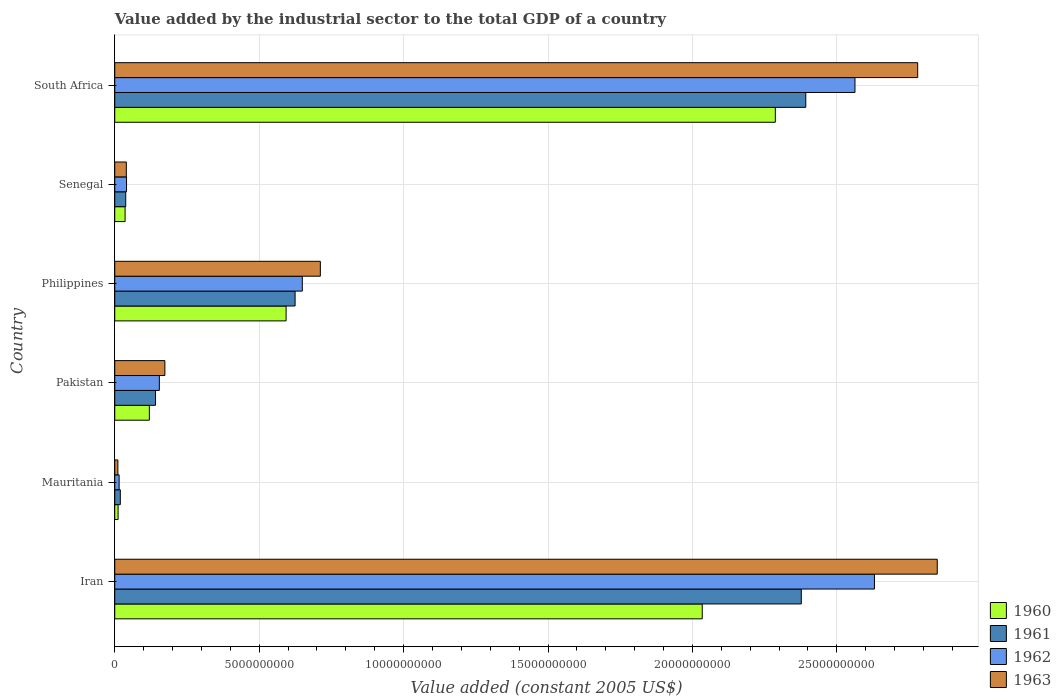Are the number of bars per tick equal to the number of legend labels?
Make the answer very short. Yes. Are the number of bars on each tick of the Y-axis equal?
Your answer should be compact. Yes. What is the label of the 5th group of bars from the top?
Provide a succinct answer. Mauritania. In how many cases, is the number of bars for a given country not equal to the number of legend labels?
Your answer should be compact. 0. What is the value added by the industrial sector in 1963 in Iran?
Provide a short and direct response. 2.85e+1. Across all countries, what is the maximum value added by the industrial sector in 1963?
Offer a terse response. 2.85e+1. Across all countries, what is the minimum value added by the industrial sector in 1962?
Your answer should be very brief. 1.51e+08. In which country was the value added by the industrial sector in 1963 maximum?
Offer a very short reply. Iran. In which country was the value added by the industrial sector in 1962 minimum?
Offer a terse response. Mauritania. What is the total value added by the industrial sector in 1960 in the graph?
Provide a succinct answer. 5.08e+1. What is the difference between the value added by the industrial sector in 1962 in Mauritania and that in Philippines?
Keep it short and to the point. -6.34e+09. What is the difference between the value added by the industrial sector in 1963 in Iran and the value added by the industrial sector in 1961 in South Africa?
Make the answer very short. 4.55e+09. What is the average value added by the industrial sector in 1963 per country?
Your answer should be compact. 1.09e+1. What is the difference between the value added by the industrial sector in 1961 and value added by the industrial sector in 1960 in Philippines?
Offer a terse response. 3.11e+08. What is the ratio of the value added by the industrial sector in 1962 in Iran to that in Pakistan?
Your answer should be compact. 17.04. What is the difference between the highest and the second highest value added by the industrial sector in 1961?
Provide a succinct answer. 1.55e+08. What is the difference between the highest and the lowest value added by the industrial sector in 1962?
Ensure brevity in your answer.  2.62e+1. In how many countries, is the value added by the industrial sector in 1961 greater than the average value added by the industrial sector in 1961 taken over all countries?
Provide a short and direct response. 2. Is it the case that in every country, the sum of the value added by the industrial sector in 1963 and value added by the industrial sector in 1961 is greater than the sum of value added by the industrial sector in 1962 and value added by the industrial sector in 1960?
Offer a very short reply. No. Is it the case that in every country, the sum of the value added by the industrial sector in 1962 and value added by the industrial sector in 1961 is greater than the value added by the industrial sector in 1960?
Offer a very short reply. Yes. How many bars are there?
Keep it short and to the point. 24. Are all the bars in the graph horizontal?
Your answer should be compact. Yes. How many countries are there in the graph?
Make the answer very short. 6. Does the graph contain grids?
Make the answer very short. Yes. Where does the legend appear in the graph?
Ensure brevity in your answer.  Bottom right. How many legend labels are there?
Ensure brevity in your answer.  4. What is the title of the graph?
Offer a terse response. Value added by the industrial sector to the total GDP of a country. Does "1977" appear as one of the legend labels in the graph?
Keep it short and to the point. No. What is the label or title of the X-axis?
Provide a succinct answer. Value added (constant 2005 US$). What is the Value added (constant 2005 US$) of 1960 in Iran?
Offer a terse response. 2.03e+1. What is the Value added (constant 2005 US$) in 1961 in Iran?
Your answer should be compact. 2.38e+1. What is the Value added (constant 2005 US$) in 1962 in Iran?
Your response must be concise. 2.63e+1. What is the Value added (constant 2005 US$) in 1963 in Iran?
Provide a succinct answer. 2.85e+1. What is the Value added (constant 2005 US$) of 1960 in Mauritania?
Offer a terse response. 1.15e+08. What is the Value added (constant 2005 US$) in 1961 in Mauritania?
Give a very brief answer. 1.92e+08. What is the Value added (constant 2005 US$) in 1962 in Mauritania?
Provide a short and direct response. 1.51e+08. What is the Value added (constant 2005 US$) in 1963 in Mauritania?
Make the answer very short. 1.08e+08. What is the Value added (constant 2005 US$) of 1960 in Pakistan?
Offer a terse response. 1.20e+09. What is the Value added (constant 2005 US$) of 1961 in Pakistan?
Your answer should be very brief. 1.41e+09. What is the Value added (constant 2005 US$) in 1962 in Pakistan?
Your answer should be compact. 1.54e+09. What is the Value added (constant 2005 US$) in 1963 in Pakistan?
Provide a short and direct response. 1.74e+09. What is the Value added (constant 2005 US$) of 1960 in Philippines?
Your answer should be very brief. 5.93e+09. What is the Value added (constant 2005 US$) of 1961 in Philippines?
Your answer should be compact. 6.24e+09. What is the Value added (constant 2005 US$) of 1962 in Philippines?
Your response must be concise. 6.49e+09. What is the Value added (constant 2005 US$) in 1963 in Philippines?
Give a very brief answer. 7.12e+09. What is the Value added (constant 2005 US$) of 1960 in Senegal?
Keep it short and to the point. 3.58e+08. What is the Value added (constant 2005 US$) of 1961 in Senegal?
Offer a terse response. 3.80e+08. What is the Value added (constant 2005 US$) in 1962 in Senegal?
Provide a short and direct response. 4.08e+08. What is the Value added (constant 2005 US$) of 1963 in Senegal?
Provide a succinct answer. 4.01e+08. What is the Value added (constant 2005 US$) of 1960 in South Africa?
Your answer should be very brief. 2.29e+1. What is the Value added (constant 2005 US$) of 1961 in South Africa?
Your response must be concise. 2.39e+1. What is the Value added (constant 2005 US$) of 1962 in South Africa?
Make the answer very short. 2.56e+1. What is the Value added (constant 2005 US$) of 1963 in South Africa?
Your response must be concise. 2.78e+1. Across all countries, what is the maximum Value added (constant 2005 US$) of 1960?
Offer a terse response. 2.29e+1. Across all countries, what is the maximum Value added (constant 2005 US$) in 1961?
Provide a short and direct response. 2.39e+1. Across all countries, what is the maximum Value added (constant 2005 US$) in 1962?
Offer a very short reply. 2.63e+1. Across all countries, what is the maximum Value added (constant 2005 US$) of 1963?
Offer a very short reply. 2.85e+1. Across all countries, what is the minimum Value added (constant 2005 US$) in 1960?
Offer a terse response. 1.15e+08. Across all countries, what is the minimum Value added (constant 2005 US$) of 1961?
Your answer should be compact. 1.92e+08. Across all countries, what is the minimum Value added (constant 2005 US$) in 1962?
Keep it short and to the point. 1.51e+08. Across all countries, what is the minimum Value added (constant 2005 US$) in 1963?
Offer a very short reply. 1.08e+08. What is the total Value added (constant 2005 US$) of 1960 in the graph?
Offer a terse response. 5.08e+1. What is the total Value added (constant 2005 US$) of 1961 in the graph?
Make the answer very short. 5.59e+1. What is the total Value added (constant 2005 US$) in 1962 in the graph?
Provide a short and direct response. 6.05e+1. What is the total Value added (constant 2005 US$) in 1963 in the graph?
Ensure brevity in your answer.  6.56e+1. What is the difference between the Value added (constant 2005 US$) of 1960 in Iran and that in Mauritania?
Make the answer very short. 2.02e+1. What is the difference between the Value added (constant 2005 US$) of 1961 in Iran and that in Mauritania?
Give a very brief answer. 2.36e+1. What is the difference between the Value added (constant 2005 US$) in 1962 in Iran and that in Mauritania?
Offer a very short reply. 2.62e+1. What is the difference between the Value added (constant 2005 US$) of 1963 in Iran and that in Mauritania?
Provide a succinct answer. 2.84e+1. What is the difference between the Value added (constant 2005 US$) of 1960 in Iran and that in Pakistan?
Your answer should be compact. 1.91e+1. What is the difference between the Value added (constant 2005 US$) in 1961 in Iran and that in Pakistan?
Make the answer very short. 2.24e+1. What is the difference between the Value added (constant 2005 US$) in 1962 in Iran and that in Pakistan?
Provide a short and direct response. 2.48e+1. What is the difference between the Value added (constant 2005 US$) in 1963 in Iran and that in Pakistan?
Ensure brevity in your answer.  2.67e+1. What is the difference between the Value added (constant 2005 US$) of 1960 in Iran and that in Philippines?
Your answer should be compact. 1.44e+1. What is the difference between the Value added (constant 2005 US$) of 1961 in Iran and that in Philippines?
Offer a terse response. 1.75e+1. What is the difference between the Value added (constant 2005 US$) of 1962 in Iran and that in Philippines?
Provide a succinct answer. 1.98e+1. What is the difference between the Value added (constant 2005 US$) of 1963 in Iran and that in Philippines?
Give a very brief answer. 2.14e+1. What is the difference between the Value added (constant 2005 US$) in 1960 in Iran and that in Senegal?
Your answer should be very brief. 2.00e+1. What is the difference between the Value added (constant 2005 US$) in 1961 in Iran and that in Senegal?
Make the answer very short. 2.34e+1. What is the difference between the Value added (constant 2005 US$) of 1962 in Iran and that in Senegal?
Your answer should be compact. 2.59e+1. What is the difference between the Value added (constant 2005 US$) of 1963 in Iran and that in Senegal?
Keep it short and to the point. 2.81e+1. What is the difference between the Value added (constant 2005 US$) of 1960 in Iran and that in South Africa?
Your answer should be very brief. -2.53e+09. What is the difference between the Value added (constant 2005 US$) in 1961 in Iran and that in South Africa?
Ensure brevity in your answer.  -1.55e+08. What is the difference between the Value added (constant 2005 US$) of 1962 in Iran and that in South Africa?
Provide a succinct answer. 6.75e+08. What is the difference between the Value added (constant 2005 US$) of 1963 in Iran and that in South Africa?
Make the answer very short. 6.77e+08. What is the difference between the Value added (constant 2005 US$) in 1960 in Mauritania and that in Pakistan?
Provide a succinct answer. -1.08e+09. What is the difference between the Value added (constant 2005 US$) in 1961 in Mauritania and that in Pakistan?
Provide a short and direct response. -1.22e+09. What is the difference between the Value added (constant 2005 US$) of 1962 in Mauritania and that in Pakistan?
Give a very brief answer. -1.39e+09. What is the difference between the Value added (constant 2005 US$) of 1963 in Mauritania and that in Pakistan?
Provide a succinct answer. -1.63e+09. What is the difference between the Value added (constant 2005 US$) of 1960 in Mauritania and that in Philippines?
Provide a short and direct response. -5.82e+09. What is the difference between the Value added (constant 2005 US$) of 1961 in Mauritania and that in Philippines?
Ensure brevity in your answer.  -6.05e+09. What is the difference between the Value added (constant 2005 US$) in 1962 in Mauritania and that in Philippines?
Your answer should be compact. -6.34e+09. What is the difference between the Value added (constant 2005 US$) of 1963 in Mauritania and that in Philippines?
Your answer should be very brief. -7.01e+09. What is the difference between the Value added (constant 2005 US$) of 1960 in Mauritania and that in Senegal?
Give a very brief answer. -2.42e+08. What is the difference between the Value added (constant 2005 US$) of 1961 in Mauritania and that in Senegal?
Offer a very short reply. -1.88e+08. What is the difference between the Value added (constant 2005 US$) of 1962 in Mauritania and that in Senegal?
Ensure brevity in your answer.  -2.56e+08. What is the difference between the Value added (constant 2005 US$) in 1963 in Mauritania and that in Senegal?
Provide a succinct answer. -2.92e+08. What is the difference between the Value added (constant 2005 US$) of 1960 in Mauritania and that in South Africa?
Give a very brief answer. -2.28e+1. What is the difference between the Value added (constant 2005 US$) of 1961 in Mauritania and that in South Africa?
Offer a terse response. -2.37e+1. What is the difference between the Value added (constant 2005 US$) of 1962 in Mauritania and that in South Africa?
Offer a terse response. -2.55e+1. What is the difference between the Value added (constant 2005 US$) in 1963 in Mauritania and that in South Africa?
Give a very brief answer. -2.77e+1. What is the difference between the Value added (constant 2005 US$) in 1960 in Pakistan and that in Philippines?
Keep it short and to the point. -4.73e+09. What is the difference between the Value added (constant 2005 US$) of 1961 in Pakistan and that in Philippines?
Provide a succinct answer. -4.83e+09. What is the difference between the Value added (constant 2005 US$) in 1962 in Pakistan and that in Philippines?
Provide a short and direct response. -4.95e+09. What is the difference between the Value added (constant 2005 US$) of 1963 in Pakistan and that in Philippines?
Provide a succinct answer. -5.38e+09. What is the difference between the Value added (constant 2005 US$) of 1960 in Pakistan and that in Senegal?
Provide a succinct answer. 8.40e+08. What is the difference between the Value added (constant 2005 US$) in 1961 in Pakistan and that in Senegal?
Give a very brief answer. 1.03e+09. What is the difference between the Value added (constant 2005 US$) in 1962 in Pakistan and that in Senegal?
Your response must be concise. 1.14e+09. What is the difference between the Value added (constant 2005 US$) in 1963 in Pakistan and that in Senegal?
Offer a very short reply. 1.33e+09. What is the difference between the Value added (constant 2005 US$) of 1960 in Pakistan and that in South Africa?
Your answer should be compact. -2.17e+1. What is the difference between the Value added (constant 2005 US$) in 1961 in Pakistan and that in South Africa?
Keep it short and to the point. -2.25e+1. What is the difference between the Value added (constant 2005 US$) in 1962 in Pakistan and that in South Africa?
Keep it short and to the point. -2.41e+1. What is the difference between the Value added (constant 2005 US$) of 1963 in Pakistan and that in South Africa?
Your answer should be very brief. -2.61e+1. What is the difference between the Value added (constant 2005 US$) of 1960 in Philippines and that in Senegal?
Provide a short and direct response. 5.57e+09. What is the difference between the Value added (constant 2005 US$) in 1961 in Philippines and that in Senegal?
Give a very brief answer. 5.86e+09. What is the difference between the Value added (constant 2005 US$) of 1962 in Philippines and that in Senegal?
Give a very brief answer. 6.09e+09. What is the difference between the Value added (constant 2005 US$) of 1963 in Philippines and that in Senegal?
Your answer should be very brief. 6.72e+09. What is the difference between the Value added (constant 2005 US$) of 1960 in Philippines and that in South Africa?
Offer a very short reply. -1.69e+1. What is the difference between the Value added (constant 2005 US$) in 1961 in Philippines and that in South Africa?
Offer a terse response. -1.77e+1. What is the difference between the Value added (constant 2005 US$) in 1962 in Philippines and that in South Africa?
Make the answer very short. -1.91e+1. What is the difference between the Value added (constant 2005 US$) of 1963 in Philippines and that in South Africa?
Provide a short and direct response. -2.07e+1. What is the difference between the Value added (constant 2005 US$) of 1960 in Senegal and that in South Africa?
Offer a terse response. -2.25e+1. What is the difference between the Value added (constant 2005 US$) of 1961 in Senegal and that in South Africa?
Your answer should be compact. -2.35e+1. What is the difference between the Value added (constant 2005 US$) in 1962 in Senegal and that in South Africa?
Provide a short and direct response. -2.52e+1. What is the difference between the Value added (constant 2005 US$) of 1963 in Senegal and that in South Africa?
Offer a very short reply. -2.74e+1. What is the difference between the Value added (constant 2005 US$) in 1960 in Iran and the Value added (constant 2005 US$) in 1961 in Mauritania?
Your answer should be very brief. 2.01e+1. What is the difference between the Value added (constant 2005 US$) of 1960 in Iran and the Value added (constant 2005 US$) of 1962 in Mauritania?
Make the answer very short. 2.02e+1. What is the difference between the Value added (constant 2005 US$) in 1960 in Iran and the Value added (constant 2005 US$) in 1963 in Mauritania?
Ensure brevity in your answer.  2.02e+1. What is the difference between the Value added (constant 2005 US$) in 1961 in Iran and the Value added (constant 2005 US$) in 1962 in Mauritania?
Your response must be concise. 2.36e+1. What is the difference between the Value added (constant 2005 US$) in 1961 in Iran and the Value added (constant 2005 US$) in 1963 in Mauritania?
Offer a very short reply. 2.37e+1. What is the difference between the Value added (constant 2005 US$) of 1962 in Iran and the Value added (constant 2005 US$) of 1963 in Mauritania?
Offer a very short reply. 2.62e+1. What is the difference between the Value added (constant 2005 US$) in 1960 in Iran and the Value added (constant 2005 US$) in 1961 in Pakistan?
Your response must be concise. 1.89e+1. What is the difference between the Value added (constant 2005 US$) of 1960 in Iran and the Value added (constant 2005 US$) of 1962 in Pakistan?
Your answer should be very brief. 1.88e+1. What is the difference between the Value added (constant 2005 US$) in 1960 in Iran and the Value added (constant 2005 US$) in 1963 in Pakistan?
Offer a terse response. 1.86e+1. What is the difference between the Value added (constant 2005 US$) of 1961 in Iran and the Value added (constant 2005 US$) of 1962 in Pakistan?
Make the answer very short. 2.22e+1. What is the difference between the Value added (constant 2005 US$) of 1961 in Iran and the Value added (constant 2005 US$) of 1963 in Pakistan?
Offer a terse response. 2.20e+1. What is the difference between the Value added (constant 2005 US$) in 1962 in Iran and the Value added (constant 2005 US$) in 1963 in Pakistan?
Give a very brief answer. 2.46e+1. What is the difference between the Value added (constant 2005 US$) of 1960 in Iran and the Value added (constant 2005 US$) of 1961 in Philippines?
Provide a succinct answer. 1.41e+1. What is the difference between the Value added (constant 2005 US$) in 1960 in Iran and the Value added (constant 2005 US$) in 1962 in Philippines?
Provide a short and direct response. 1.38e+1. What is the difference between the Value added (constant 2005 US$) of 1960 in Iran and the Value added (constant 2005 US$) of 1963 in Philippines?
Ensure brevity in your answer.  1.32e+1. What is the difference between the Value added (constant 2005 US$) in 1961 in Iran and the Value added (constant 2005 US$) in 1962 in Philippines?
Ensure brevity in your answer.  1.73e+1. What is the difference between the Value added (constant 2005 US$) in 1961 in Iran and the Value added (constant 2005 US$) in 1963 in Philippines?
Give a very brief answer. 1.67e+1. What is the difference between the Value added (constant 2005 US$) of 1962 in Iran and the Value added (constant 2005 US$) of 1963 in Philippines?
Keep it short and to the point. 1.92e+1. What is the difference between the Value added (constant 2005 US$) in 1960 in Iran and the Value added (constant 2005 US$) in 1961 in Senegal?
Ensure brevity in your answer.  2.00e+1. What is the difference between the Value added (constant 2005 US$) in 1960 in Iran and the Value added (constant 2005 US$) in 1962 in Senegal?
Ensure brevity in your answer.  1.99e+1. What is the difference between the Value added (constant 2005 US$) of 1960 in Iran and the Value added (constant 2005 US$) of 1963 in Senegal?
Your answer should be compact. 1.99e+1. What is the difference between the Value added (constant 2005 US$) in 1961 in Iran and the Value added (constant 2005 US$) in 1962 in Senegal?
Provide a short and direct response. 2.34e+1. What is the difference between the Value added (constant 2005 US$) in 1961 in Iran and the Value added (constant 2005 US$) in 1963 in Senegal?
Offer a terse response. 2.34e+1. What is the difference between the Value added (constant 2005 US$) of 1962 in Iran and the Value added (constant 2005 US$) of 1963 in Senegal?
Keep it short and to the point. 2.59e+1. What is the difference between the Value added (constant 2005 US$) in 1960 in Iran and the Value added (constant 2005 US$) in 1961 in South Africa?
Give a very brief answer. -3.58e+09. What is the difference between the Value added (constant 2005 US$) of 1960 in Iran and the Value added (constant 2005 US$) of 1962 in South Africa?
Your response must be concise. -5.29e+09. What is the difference between the Value added (constant 2005 US$) of 1960 in Iran and the Value added (constant 2005 US$) of 1963 in South Africa?
Keep it short and to the point. -7.46e+09. What is the difference between the Value added (constant 2005 US$) of 1961 in Iran and the Value added (constant 2005 US$) of 1962 in South Africa?
Provide a short and direct response. -1.86e+09. What is the difference between the Value added (constant 2005 US$) of 1961 in Iran and the Value added (constant 2005 US$) of 1963 in South Africa?
Ensure brevity in your answer.  -4.03e+09. What is the difference between the Value added (constant 2005 US$) of 1962 in Iran and the Value added (constant 2005 US$) of 1963 in South Africa?
Keep it short and to the point. -1.50e+09. What is the difference between the Value added (constant 2005 US$) of 1960 in Mauritania and the Value added (constant 2005 US$) of 1961 in Pakistan?
Offer a terse response. -1.30e+09. What is the difference between the Value added (constant 2005 US$) in 1960 in Mauritania and the Value added (constant 2005 US$) in 1962 in Pakistan?
Ensure brevity in your answer.  -1.43e+09. What is the difference between the Value added (constant 2005 US$) of 1960 in Mauritania and the Value added (constant 2005 US$) of 1963 in Pakistan?
Offer a terse response. -1.62e+09. What is the difference between the Value added (constant 2005 US$) of 1961 in Mauritania and the Value added (constant 2005 US$) of 1962 in Pakistan?
Offer a terse response. -1.35e+09. What is the difference between the Value added (constant 2005 US$) of 1961 in Mauritania and the Value added (constant 2005 US$) of 1963 in Pakistan?
Make the answer very short. -1.54e+09. What is the difference between the Value added (constant 2005 US$) of 1962 in Mauritania and the Value added (constant 2005 US$) of 1963 in Pakistan?
Offer a very short reply. -1.58e+09. What is the difference between the Value added (constant 2005 US$) in 1960 in Mauritania and the Value added (constant 2005 US$) in 1961 in Philippines?
Your response must be concise. -6.13e+09. What is the difference between the Value added (constant 2005 US$) in 1960 in Mauritania and the Value added (constant 2005 US$) in 1962 in Philippines?
Provide a succinct answer. -6.38e+09. What is the difference between the Value added (constant 2005 US$) in 1960 in Mauritania and the Value added (constant 2005 US$) in 1963 in Philippines?
Keep it short and to the point. -7.00e+09. What is the difference between the Value added (constant 2005 US$) of 1961 in Mauritania and the Value added (constant 2005 US$) of 1962 in Philippines?
Give a very brief answer. -6.30e+09. What is the difference between the Value added (constant 2005 US$) in 1961 in Mauritania and the Value added (constant 2005 US$) in 1963 in Philippines?
Keep it short and to the point. -6.93e+09. What is the difference between the Value added (constant 2005 US$) in 1962 in Mauritania and the Value added (constant 2005 US$) in 1963 in Philippines?
Provide a succinct answer. -6.97e+09. What is the difference between the Value added (constant 2005 US$) of 1960 in Mauritania and the Value added (constant 2005 US$) of 1961 in Senegal?
Provide a short and direct response. -2.65e+08. What is the difference between the Value added (constant 2005 US$) in 1960 in Mauritania and the Value added (constant 2005 US$) in 1962 in Senegal?
Keep it short and to the point. -2.92e+08. What is the difference between the Value added (constant 2005 US$) in 1960 in Mauritania and the Value added (constant 2005 US$) in 1963 in Senegal?
Keep it short and to the point. -2.85e+08. What is the difference between the Value added (constant 2005 US$) of 1961 in Mauritania and the Value added (constant 2005 US$) of 1962 in Senegal?
Your answer should be very brief. -2.15e+08. What is the difference between the Value added (constant 2005 US$) of 1961 in Mauritania and the Value added (constant 2005 US$) of 1963 in Senegal?
Keep it short and to the point. -2.08e+08. What is the difference between the Value added (constant 2005 US$) of 1962 in Mauritania and the Value added (constant 2005 US$) of 1963 in Senegal?
Your answer should be compact. -2.49e+08. What is the difference between the Value added (constant 2005 US$) of 1960 in Mauritania and the Value added (constant 2005 US$) of 1961 in South Africa?
Keep it short and to the point. -2.38e+1. What is the difference between the Value added (constant 2005 US$) of 1960 in Mauritania and the Value added (constant 2005 US$) of 1962 in South Africa?
Your answer should be compact. -2.55e+1. What is the difference between the Value added (constant 2005 US$) in 1960 in Mauritania and the Value added (constant 2005 US$) in 1963 in South Africa?
Give a very brief answer. -2.77e+1. What is the difference between the Value added (constant 2005 US$) in 1961 in Mauritania and the Value added (constant 2005 US$) in 1962 in South Africa?
Make the answer very short. -2.54e+1. What is the difference between the Value added (constant 2005 US$) of 1961 in Mauritania and the Value added (constant 2005 US$) of 1963 in South Africa?
Offer a very short reply. -2.76e+1. What is the difference between the Value added (constant 2005 US$) of 1962 in Mauritania and the Value added (constant 2005 US$) of 1963 in South Africa?
Your answer should be very brief. -2.76e+1. What is the difference between the Value added (constant 2005 US$) of 1960 in Pakistan and the Value added (constant 2005 US$) of 1961 in Philippines?
Offer a very short reply. -5.05e+09. What is the difference between the Value added (constant 2005 US$) in 1960 in Pakistan and the Value added (constant 2005 US$) in 1962 in Philippines?
Give a very brief answer. -5.30e+09. What is the difference between the Value added (constant 2005 US$) in 1960 in Pakistan and the Value added (constant 2005 US$) in 1963 in Philippines?
Your answer should be compact. -5.92e+09. What is the difference between the Value added (constant 2005 US$) in 1961 in Pakistan and the Value added (constant 2005 US$) in 1962 in Philippines?
Your answer should be compact. -5.08e+09. What is the difference between the Value added (constant 2005 US$) in 1961 in Pakistan and the Value added (constant 2005 US$) in 1963 in Philippines?
Keep it short and to the point. -5.71e+09. What is the difference between the Value added (constant 2005 US$) of 1962 in Pakistan and the Value added (constant 2005 US$) of 1963 in Philippines?
Ensure brevity in your answer.  -5.57e+09. What is the difference between the Value added (constant 2005 US$) in 1960 in Pakistan and the Value added (constant 2005 US$) in 1961 in Senegal?
Your response must be concise. 8.18e+08. What is the difference between the Value added (constant 2005 US$) of 1960 in Pakistan and the Value added (constant 2005 US$) of 1962 in Senegal?
Make the answer very short. 7.91e+08. What is the difference between the Value added (constant 2005 US$) of 1960 in Pakistan and the Value added (constant 2005 US$) of 1963 in Senegal?
Make the answer very short. 7.98e+08. What is the difference between the Value added (constant 2005 US$) of 1961 in Pakistan and the Value added (constant 2005 US$) of 1962 in Senegal?
Keep it short and to the point. 1.00e+09. What is the difference between the Value added (constant 2005 US$) of 1961 in Pakistan and the Value added (constant 2005 US$) of 1963 in Senegal?
Give a very brief answer. 1.01e+09. What is the difference between the Value added (constant 2005 US$) of 1962 in Pakistan and the Value added (constant 2005 US$) of 1963 in Senegal?
Provide a short and direct response. 1.14e+09. What is the difference between the Value added (constant 2005 US$) of 1960 in Pakistan and the Value added (constant 2005 US$) of 1961 in South Africa?
Provide a succinct answer. -2.27e+1. What is the difference between the Value added (constant 2005 US$) in 1960 in Pakistan and the Value added (constant 2005 US$) in 1962 in South Africa?
Your answer should be compact. -2.44e+1. What is the difference between the Value added (constant 2005 US$) of 1960 in Pakistan and the Value added (constant 2005 US$) of 1963 in South Africa?
Provide a short and direct response. -2.66e+1. What is the difference between the Value added (constant 2005 US$) in 1961 in Pakistan and the Value added (constant 2005 US$) in 1962 in South Africa?
Ensure brevity in your answer.  -2.42e+1. What is the difference between the Value added (constant 2005 US$) of 1961 in Pakistan and the Value added (constant 2005 US$) of 1963 in South Africa?
Keep it short and to the point. -2.64e+1. What is the difference between the Value added (constant 2005 US$) in 1962 in Pakistan and the Value added (constant 2005 US$) in 1963 in South Africa?
Your answer should be very brief. -2.63e+1. What is the difference between the Value added (constant 2005 US$) of 1960 in Philippines and the Value added (constant 2005 US$) of 1961 in Senegal?
Make the answer very short. 5.55e+09. What is the difference between the Value added (constant 2005 US$) in 1960 in Philippines and the Value added (constant 2005 US$) in 1962 in Senegal?
Provide a short and direct response. 5.53e+09. What is the difference between the Value added (constant 2005 US$) in 1960 in Philippines and the Value added (constant 2005 US$) in 1963 in Senegal?
Keep it short and to the point. 5.53e+09. What is the difference between the Value added (constant 2005 US$) in 1961 in Philippines and the Value added (constant 2005 US$) in 1962 in Senegal?
Provide a short and direct response. 5.84e+09. What is the difference between the Value added (constant 2005 US$) of 1961 in Philippines and the Value added (constant 2005 US$) of 1963 in Senegal?
Ensure brevity in your answer.  5.84e+09. What is the difference between the Value added (constant 2005 US$) in 1962 in Philippines and the Value added (constant 2005 US$) in 1963 in Senegal?
Offer a very short reply. 6.09e+09. What is the difference between the Value added (constant 2005 US$) in 1960 in Philippines and the Value added (constant 2005 US$) in 1961 in South Africa?
Make the answer very short. -1.80e+1. What is the difference between the Value added (constant 2005 US$) in 1960 in Philippines and the Value added (constant 2005 US$) in 1962 in South Africa?
Ensure brevity in your answer.  -1.97e+1. What is the difference between the Value added (constant 2005 US$) of 1960 in Philippines and the Value added (constant 2005 US$) of 1963 in South Africa?
Your answer should be very brief. -2.19e+1. What is the difference between the Value added (constant 2005 US$) of 1961 in Philippines and the Value added (constant 2005 US$) of 1962 in South Africa?
Offer a terse response. -1.94e+1. What is the difference between the Value added (constant 2005 US$) of 1961 in Philippines and the Value added (constant 2005 US$) of 1963 in South Africa?
Offer a terse response. -2.16e+1. What is the difference between the Value added (constant 2005 US$) of 1962 in Philippines and the Value added (constant 2005 US$) of 1963 in South Africa?
Provide a short and direct response. -2.13e+1. What is the difference between the Value added (constant 2005 US$) in 1960 in Senegal and the Value added (constant 2005 US$) in 1961 in South Africa?
Provide a succinct answer. -2.36e+1. What is the difference between the Value added (constant 2005 US$) in 1960 in Senegal and the Value added (constant 2005 US$) in 1962 in South Africa?
Your answer should be compact. -2.53e+1. What is the difference between the Value added (constant 2005 US$) in 1960 in Senegal and the Value added (constant 2005 US$) in 1963 in South Africa?
Ensure brevity in your answer.  -2.74e+1. What is the difference between the Value added (constant 2005 US$) of 1961 in Senegal and the Value added (constant 2005 US$) of 1962 in South Africa?
Give a very brief answer. -2.52e+1. What is the difference between the Value added (constant 2005 US$) in 1961 in Senegal and the Value added (constant 2005 US$) in 1963 in South Africa?
Offer a terse response. -2.74e+1. What is the difference between the Value added (constant 2005 US$) of 1962 in Senegal and the Value added (constant 2005 US$) of 1963 in South Africa?
Ensure brevity in your answer.  -2.74e+1. What is the average Value added (constant 2005 US$) in 1960 per country?
Your answer should be very brief. 8.47e+09. What is the average Value added (constant 2005 US$) in 1961 per country?
Give a very brief answer. 9.32e+09. What is the average Value added (constant 2005 US$) of 1962 per country?
Keep it short and to the point. 1.01e+1. What is the average Value added (constant 2005 US$) in 1963 per country?
Offer a terse response. 1.09e+1. What is the difference between the Value added (constant 2005 US$) in 1960 and Value added (constant 2005 US$) in 1961 in Iran?
Offer a terse response. -3.43e+09. What is the difference between the Value added (constant 2005 US$) in 1960 and Value added (constant 2005 US$) in 1962 in Iran?
Give a very brief answer. -5.96e+09. What is the difference between the Value added (constant 2005 US$) in 1960 and Value added (constant 2005 US$) in 1963 in Iran?
Provide a short and direct response. -8.14e+09. What is the difference between the Value added (constant 2005 US$) of 1961 and Value added (constant 2005 US$) of 1962 in Iran?
Provide a short and direct response. -2.53e+09. What is the difference between the Value added (constant 2005 US$) in 1961 and Value added (constant 2005 US$) in 1963 in Iran?
Provide a succinct answer. -4.71e+09. What is the difference between the Value added (constant 2005 US$) in 1962 and Value added (constant 2005 US$) in 1963 in Iran?
Provide a succinct answer. -2.17e+09. What is the difference between the Value added (constant 2005 US$) in 1960 and Value added (constant 2005 US$) in 1961 in Mauritania?
Provide a short and direct response. -7.68e+07. What is the difference between the Value added (constant 2005 US$) of 1960 and Value added (constant 2005 US$) of 1962 in Mauritania?
Your answer should be very brief. -3.59e+07. What is the difference between the Value added (constant 2005 US$) of 1960 and Value added (constant 2005 US$) of 1963 in Mauritania?
Ensure brevity in your answer.  7.13e+06. What is the difference between the Value added (constant 2005 US$) in 1961 and Value added (constant 2005 US$) in 1962 in Mauritania?
Keep it short and to the point. 4.09e+07. What is the difference between the Value added (constant 2005 US$) in 1961 and Value added (constant 2005 US$) in 1963 in Mauritania?
Make the answer very short. 8.39e+07. What is the difference between the Value added (constant 2005 US$) in 1962 and Value added (constant 2005 US$) in 1963 in Mauritania?
Offer a terse response. 4.31e+07. What is the difference between the Value added (constant 2005 US$) of 1960 and Value added (constant 2005 US$) of 1961 in Pakistan?
Provide a succinct answer. -2.14e+08. What is the difference between the Value added (constant 2005 US$) in 1960 and Value added (constant 2005 US$) in 1962 in Pakistan?
Your answer should be compact. -3.45e+08. What is the difference between the Value added (constant 2005 US$) of 1960 and Value added (constant 2005 US$) of 1963 in Pakistan?
Your response must be concise. -5.37e+08. What is the difference between the Value added (constant 2005 US$) in 1961 and Value added (constant 2005 US$) in 1962 in Pakistan?
Your response must be concise. -1.32e+08. What is the difference between the Value added (constant 2005 US$) in 1961 and Value added (constant 2005 US$) in 1963 in Pakistan?
Provide a succinct answer. -3.23e+08. What is the difference between the Value added (constant 2005 US$) in 1962 and Value added (constant 2005 US$) in 1963 in Pakistan?
Offer a terse response. -1.92e+08. What is the difference between the Value added (constant 2005 US$) of 1960 and Value added (constant 2005 US$) of 1961 in Philippines?
Make the answer very short. -3.11e+08. What is the difference between the Value added (constant 2005 US$) of 1960 and Value added (constant 2005 US$) of 1962 in Philippines?
Give a very brief answer. -5.61e+08. What is the difference between the Value added (constant 2005 US$) in 1960 and Value added (constant 2005 US$) in 1963 in Philippines?
Offer a very short reply. -1.18e+09. What is the difference between the Value added (constant 2005 US$) in 1961 and Value added (constant 2005 US$) in 1962 in Philippines?
Provide a short and direct response. -2.50e+08. What is the difference between the Value added (constant 2005 US$) in 1961 and Value added (constant 2005 US$) in 1963 in Philippines?
Your answer should be very brief. -8.74e+08. What is the difference between the Value added (constant 2005 US$) of 1962 and Value added (constant 2005 US$) of 1963 in Philippines?
Your response must be concise. -6.24e+08. What is the difference between the Value added (constant 2005 US$) of 1960 and Value added (constant 2005 US$) of 1961 in Senegal?
Make the answer very short. -2.25e+07. What is the difference between the Value added (constant 2005 US$) of 1960 and Value added (constant 2005 US$) of 1962 in Senegal?
Your answer should be very brief. -4.98e+07. What is the difference between the Value added (constant 2005 US$) in 1960 and Value added (constant 2005 US$) in 1963 in Senegal?
Ensure brevity in your answer.  -4.27e+07. What is the difference between the Value added (constant 2005 US$) of 1961 and Value added (constant 2005 US$) of 1962 in Senegal?
Provide a succinct answer. -2.72e+07. What is the difference between the Value added (constant 2005 US$) in 1961 and Value added (constant 2005 US$) in 1963 in Senegal?
Provide a short and direct response. -2.02e+07. What is the difference between the Value added (constant 2005 US$) of 1962 and Value added (constant 2005 US$) of 1963 in Senegal?
Your answer should be very brief. 7.03e+06. What is the difference between the Value added (constant 2005 US$) of 1960 and Value added (constant 2005 US$) of 1961 in South Africa?
Your answer should be compact. -1.05e+09. What is the difference between the Value added (constant 2005 US$) in 1960 and Value added (constant 2005 US$) in 1962 in South Africa?
Keep it short and to the point. -2.76e+09. What is the difference between the Value added (constant 2005 US$) in 1960 and Value added (constant 2005 US$) in 1963 in South Africa?
Provide a short and direct response. -4.93e+09. What is the difference between the Value added (constant 2005 US$) of 1961 and Value added (constant 2005 US$) of 1962 in South Africa?
Provide a short and direct response. -1.70e+09. What is the difference between the Value added (constant 2005 US$) of 1961 and Value added (constant 2005 US$) of 1963 in South Africa?
Provide a short and direct response. -3.87e+09. What is the difference between the Value added (constant 2005 US$) in 1962 and Value added (constant 2005 US$) in 1963 in South Africa?
Make the answer very short. -2.17e+09. What is the ratio of the Value added (constant 2005 US$) of 1960 in Iran to that in Mauritania?
Keep it short and to the point. 176.32. What is the ratio of the Value added (constant 2005 US$) of 1961 in Iran to that in Mauritania?
Ensure brevity in your answer.  123.7. What is the ratio of the Value added (constant 2005 US$) of 1962 in Iran to that in Mauritania?
Give a very brief answer. 173.84. What is the ratio of the Value added (constant 2005 US$) in 1963 in Iran to that in Mauritania?
Give a very brief answer. 263.11. What is the ratio of the Value added (constant 2005 US$) of 1960 in Iran to that in Pakistan?
Ensure brevity in your answer.  16.98. What is the ratio of the Value added (constant 2005 US$) in 1961 in Iran to that in Pakistan?
Your answer should be compact. 16.84. What is the ratio of the Value added (constant 2005 US$) of 1962 in Iran to that in Pakistan?
Provide a short and direct response. 17.04. What is the ratio of the Value added (constant 2005 US$) in 1963 in Iran to that in Pakistan?
Offer a terse response. 16.41. What is the ratio of the Value added (constant 2005 US$) of 1960 in Iran to that in Philippines?
Make the answer very short. 3.43. What is the ratio of the Value added (constant 2005 US$) of 1961 in Iran to that in Philippines?
Your answer should be compact. 3.81. What is the ratio of the Value added (constant 2005 US$) in 1962 in Iran to that in Philippines?
Ensure brevity in your answer.  4.05. What is the ratio of the Value added (constant 2005 US$) in 1963 in Iran to that in Philippines?
Your response must be concise. 4. What is the ratio of the Value added (constant 2005 US$) in 1960 in Iran to that in Senegal?
Make the answer very short. 56.85. What is the ratio of the Value added (constant 2005 US$) in 1961 in Iran to that in Senegal?
Your answer should be compact. 62.5. What is the ratio of the Value added (constant 2005 US$) in 1962 in Iran to that in Senegal?
Keep it short and to the point. 64.54. What is the ratio of the Value added (constant 2005 US$) of 1963 in Iran to that in Senegal?
Offer a terse response. 71.1. What is the ratio of the Value added (constant 2005 US$) of 1960 in Iran to that in South Africa?
Offer a very short reply. 0.89. What is the ratio of the Value added (constant 2005 US$) of 1961 in Iran to that in South Africa?
Keep it short and to the point. 0.99. What is the ratio of the Value added (constant 2005 US$) in 1962 in Iran to that in South Africa?
Your answer should be compact. 1.03. What is the ratio of the Value added (constant 2005 US$) of 1963 in Iran to that in South Africa?
Your answer should be compact. 1.02. What is the ratio of the Value added (constant 2005 US$) in 1960 in Mauritania to that in Pakistan?
Offer a terse response. 0.1. What is the ratio of the Value added (constant 2005 US$) in 1961 in Mauritania to that in Pakistan?
Offer a very short reply. 0.14. What is the ratio of the Value added (constant 2005 US$) in 1962 in Mauritania to that in Pakistan?
Keep it short and to the point. 0.1. What is the ratio of the Value added (constant 2005 US$) in 1963 in Mauritania to that in Pakistan?
Make the answer very short. 0.06. What is the ratio of the Value added (constant 2005 US$) of 1960 in Mauritania to that in Philippines?
Give a very brief answer. 0.02. What is the ratio of the Value added (constant 2005 US$) of 1961 in Mauritania to that in Philippines?
Offer a very short reply. 0.03. What is the ratio of the Value added (constant 2005 US$) of 1962 in Mauritania to that in Philippines?
Provide a succinct answer. 0.02. What is the ratio of the Value added (constant 2005 US$) of 1963 in Mauritania to that in Philippines?
Your answer should be very brief. 0.02. What is the ratio of the Value added (constant 2005 US$) of 1960 in Mauritania to that in Senegal?
Offer a terse response. 0.32. What is the ratio of the Value added (constant 2005 US$) of 1961 in Mauritania to that in Senegal?
Keep it short and to the point. 0.51. What is the ratio of the Value added (constant 2005 US$) of 1962 in Mauritania to that in Senegal?
Provide a short and direct response. 0.37. What is the ratio of the Value added (constant 2005 US$) in 1963 in Mauritania to that in Senegal?
Your answer should be compact. 0.27. What is the ratio of the Value added (constant 2005 US$) in 1960 in Mauritania to that in South Africa?
Your answer should be compact. 0.01. What is the ratio of the Value added (constant 2005 US$) in 1961 in Mauritania to that in South Africa?
Give a very brief answer. 0.01. What is the ratio of the Value added (constant 2005 US$) of 1962 in Mauritania to that in South Africa?
Your answer should be compact. 0.01. What is the ratio of the Value added (constant 2005 US$) of 1963 in Mauritania to that in South Africa?
Offer a terse response. 0. What is the ratio of the Value added (constant 2005 US$) in 1960 in Pakistan to that in Philippines?
Make the answer very short. 0.2. What is the ratio of the Value added (constant 2005 US$) of 1961 in Pakistan to that in Philippines?
Provide a short and direct response. 0.23. What is the ratio of the Value added (constant 2005 US$) in 1962 in Pakistan to that in Philippines?
Your response must be concise. 0.24. What is the ratio of the Value added (constant 2005 US$) of 1963 in Pakistan to that in Philippines?
Offer a very short reply. 0.24. What is the ratio of the Value added (constant 2005 US$) in 1960 in Pakistan to that in Senegal?
Keep it short and to the point. 3.35. What is the ratio of the Value added (constant 2005 US$) of 1961 in Pakistan to that in Senegal?
Provide a short and direct response. 3.71. What is the ratio of the Value added (constant 2005 US$) of 1962 in Pakistan to that in Senegal?
Offer a very short reply. 3.79. What is the ratio of the Value added (constant 2005 US$) of 1963 in Pakistan to that in Senegal?
Provide a succinct answer. 4.33. What is the ratio of the Value added (constant 2005 US$) in 1960 in Pakistan to that in South Africa?
Give a very brief answer. 0.05. What is the ratio of the Value added (constant 2005 US$) of 1961 in Pakistan to that in South Africa?
Make the answer very short. 0.06. What is the ratio of the Value added (constant 2005 US$) of 1962 in Pakistan to that in South Africa?
Ensure brevity in your answer.  0.06. What is the ratio of the Value added (constant 2005 US$) of 1963 in Pakistan to that in South Africa?
Offer a very short reply. 0.06. What is the ratio of the Value added (constant 2005 US$) of 1960 in Philippines to that in Senegal?
Your response must be concise. 16.58. What is the ratio of the Value added (constant 2005 US$) of 1961 in Philippines to that in Senegal?
Offer a terse response. 16.42. What is the ratio of the Value added (constant 2005 US$) of 1962 in Philippines to that in Senegal?
Your response must be concise. 15.93. What is the ratio of the Value added (constant 2005 US$) in 1963 in Philippines to that in Senegal?
Offer a very short reply. 17.77. What is the ratio of the Value added (constant 2005 US$) in 1960 in Philippines to that in South Africa?
Your response must be concise. 0.26. What is the ratio of the Value added (constant 2005 US$) of 1961 in Philippines to that in South Africa?
Your answer should be very brief. 0.26. What is the ratio of the Value added (constant 2005 US$) in 1962 in Philippines to that in South Africa?
Ensure brevity in your answer.  0.25. What is the ratio of the Value added (constant 2005 US$) of 1963 in Philippines to that in South Africa?
Give a very brief answer. 0.26. What is the ratio of the Value added (constant 2005 US$) of 1960 in Senegal to that in South Africa?
Your answer should be very brief. 0.02. What is the ratio of the Value added (constant 2005 US$) of 1961 in Senegal to that in South Africa?
Ensure brevity in your answer.  0.02. What is the ratio of the Value added (constant 2005 US$) of 1962 in Senegal to that in South Africa?
Give a very brief answer. 0.02. What is the ratio of the Value added (constant 2005 US$) in 1963 in Senegal to that in South Africa?
Your response must be concise. 0.01. What is the difference between the highest and the second highest Value added (constant 2005 US$) in 1960?
Provide a succinct answer. 2.53e+09. What is the difference between the highest and the second highest Value added (constant 2005 US$) in 1961?
Provide a short and direct response. 1.55e+08. What is the difference between the highest and the second highest Value added (constant 2005 US$) of 1962?
Give a very brief answer. 6.75e+08. What is the difference between the highest and the second highest Value added (constant 2005 US$) in 1963?
Make the answer very short. 6.77e+08. What is the difference between the highest and the lowest Value added (constant 2005 US$) in 1960?
Ensure brevity in your answer.  2.28e+1. What is the difference between the highest and the lowest Value added (constant 2005 US$) of 1961?
Your answer should be very brief. 2.37e+1. What is the difference between the highest and the lowest Value added (constant 2005 US$) in 1962?
Provide a short and direct response. 2.62e+1. What is the difference between the highest and the lowest Value added (constant 2005 US$) in 1963?
Make the answer very short. 2.84e+1. 